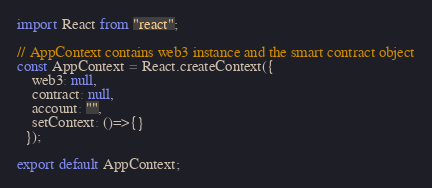<code> <loc_0><loc_0><loc_500><loc_500><_JavaScript_>import React from "react";

// AppContext contains web3 instance and the smart contract object
const AppContext = React.createContext({
    web3: null,
    contract: null,
    account: "",
    setContext: ()=>{}
  });

export default AppContext;</code> 